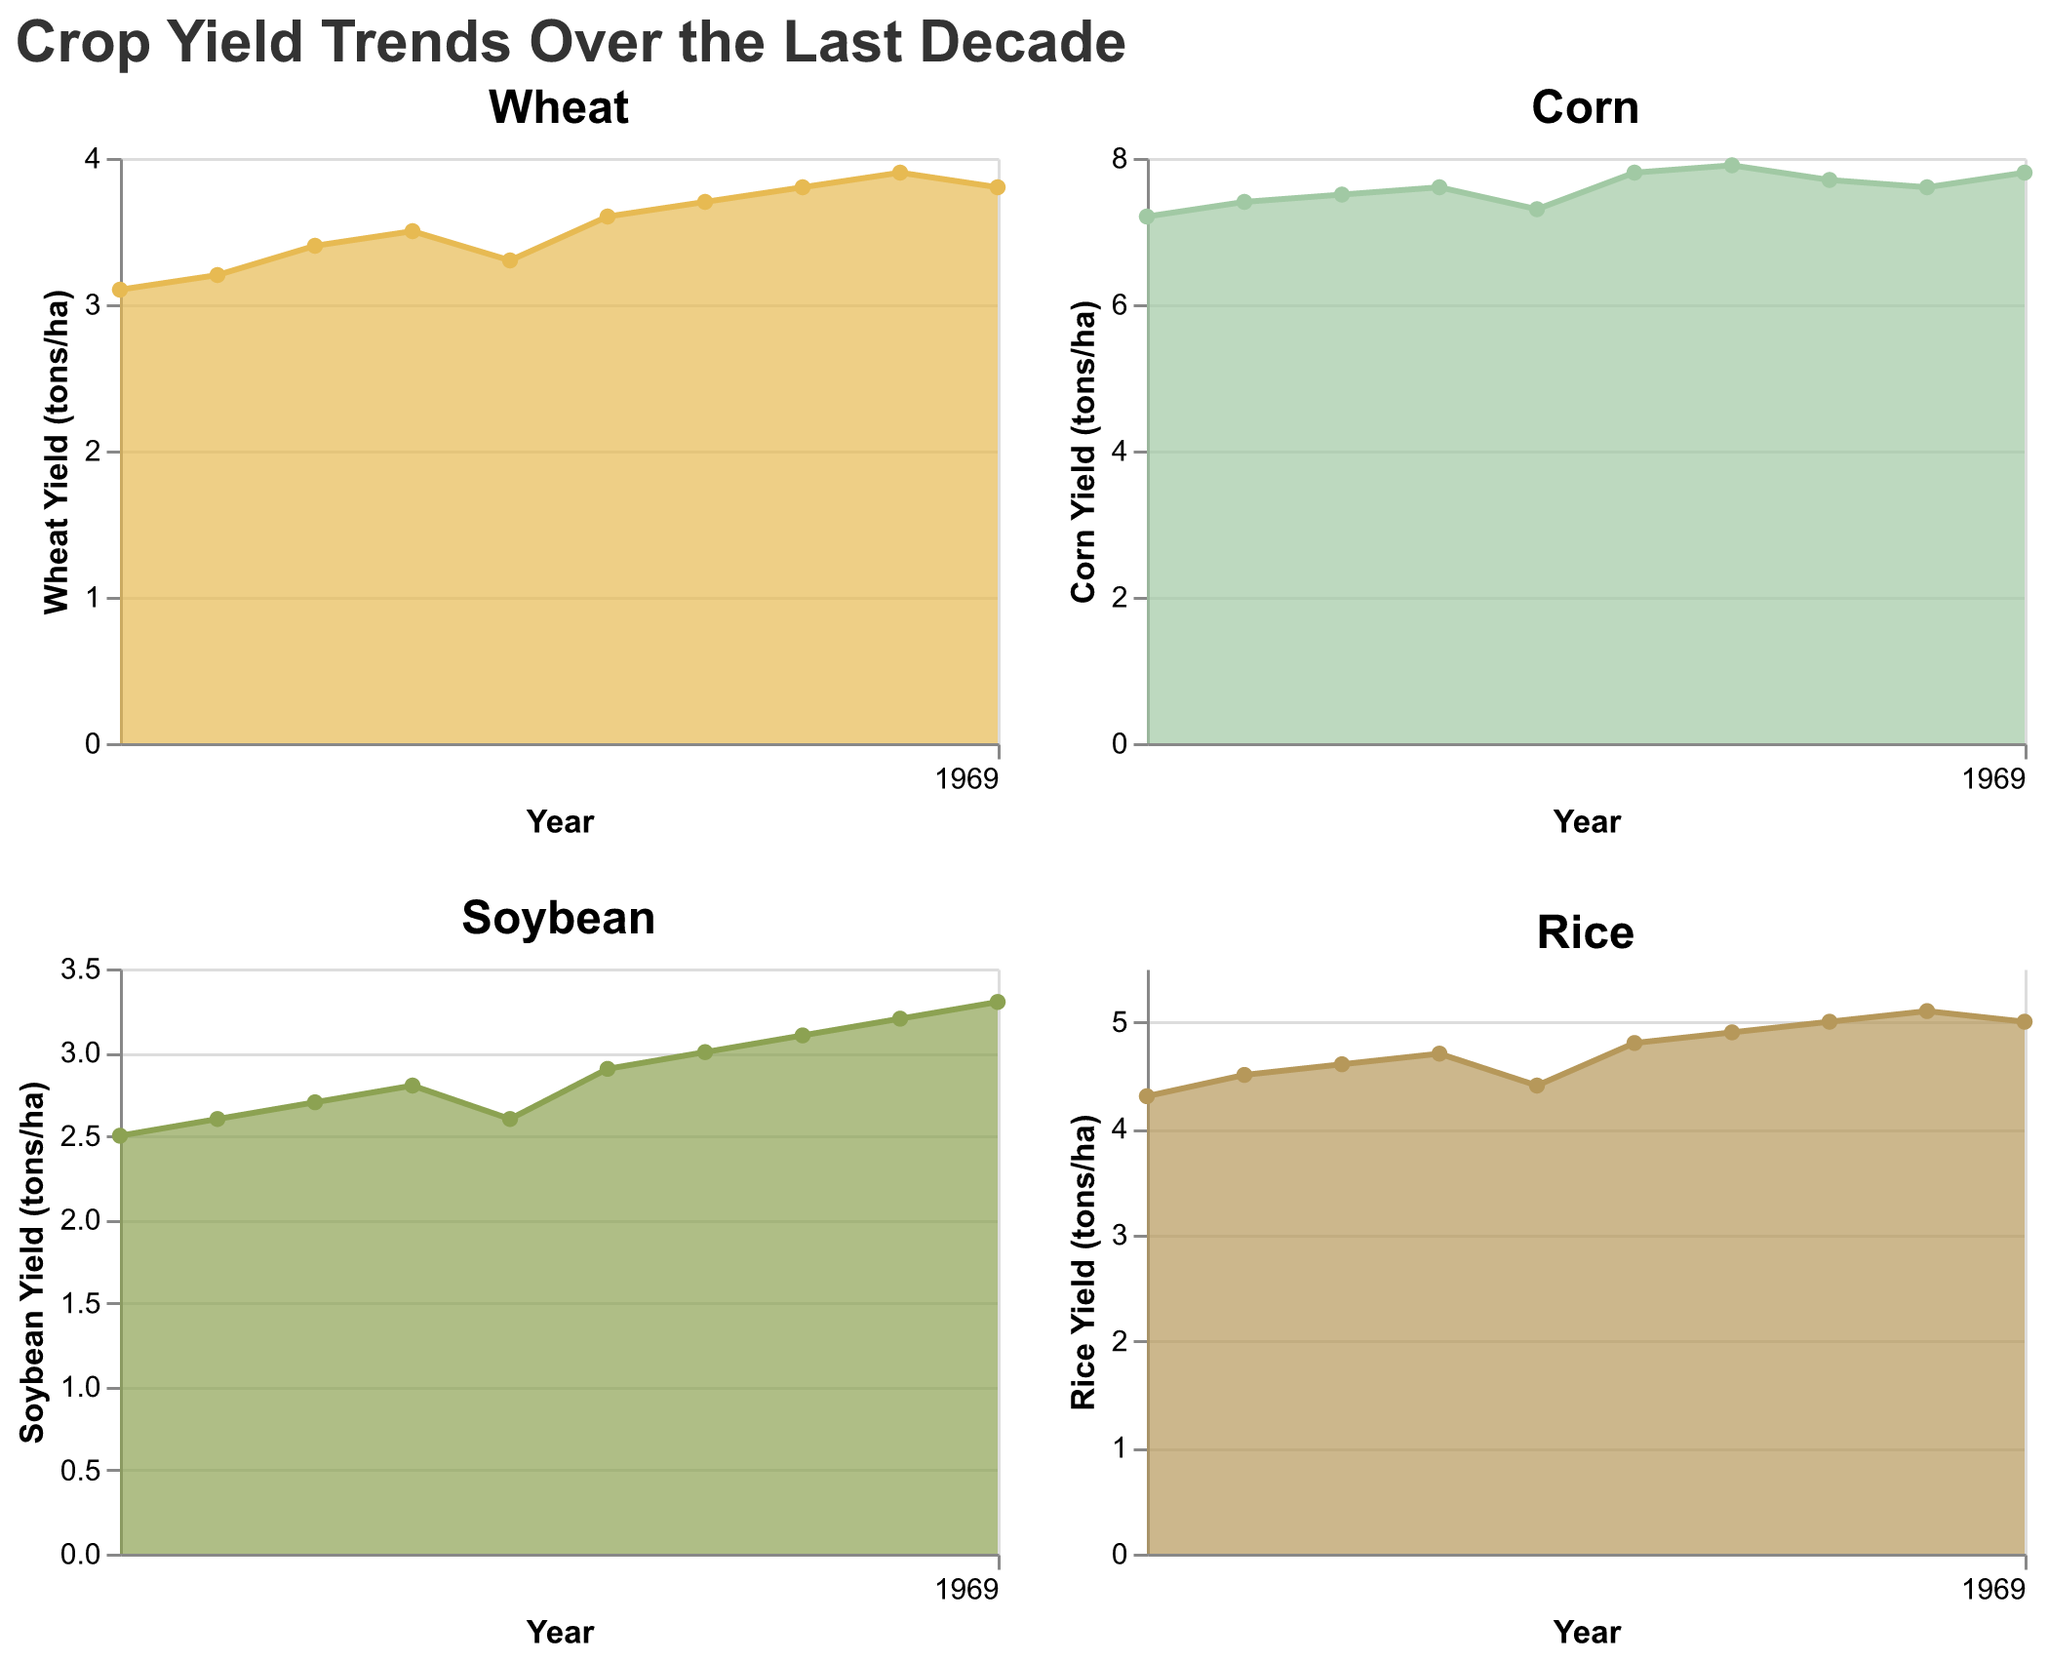What is the title of the figure? Look at the top of the figure where the title is placed. It provides an overview of what the chart is about.
Answer: Crop Yield Trends Over the Last Decade How many subplots are there in the figure? Count the individual charts within the figure to determine the number of subplots.
Answer: 4 Which crop had the highest yield in 2015? Compare the yield values for Wheat, Corn, Soybean, and Rice in the year 2015. Corn has the highest yield with 7.5 tons/ha.
Answer: Corn How did the yield of Rice change from 2018 to 2022? Look at the Rice yield values for the years 2018, 2019, 2020, 2021, and 2022. Observe the trend and note the increase or decrease. Rice yield remained relatively stable, moving from 4.8 to 5.0 tons/ha.
Answer: It increased slightly What is the average yield of Soybean over the last decade? Sum up the Soybean yields from 2013 to 2022 and divide by the number of years (10). The total yield is 29.7, so the average yield is 29.7 / 10 = 2.97 tons/ha.
Answer: 2.97 tons/ha Did any crop experience a decrease in yield from one year to the next? Examine each subplot for any instance where the yield decreases from one year to the next. For example, Wheat yield decreased from 3.9 to 3.8 in 2022.
Answer: Yes (Wheat from 2021 to 2022) Which crop shows the most consistent increase in yield over the decade? Compare the trends for Wheat, Corn, Soybean, and Rice. Corn shows an almost consistent increase over the years with minor variations.
Answer: Corn What was the yield of Wheat in 2020? Check the Wheat subplot and look at the yield value for the year 2020. It was 3.8 tons/ha.
Answer: 3.8 tons/ha In which year did Soybean yield reach 3.0 tons/ha? Look at the Soybean subplot and find the year when the yield reached 3.0 tons/ha. It was in 2019.
Answer: 2019 What is the color used for representing Corn yield in the area chart? Check the color encoding for the Corn subplot. It is a shade of green (#a1c9a4).
Answer: Green 